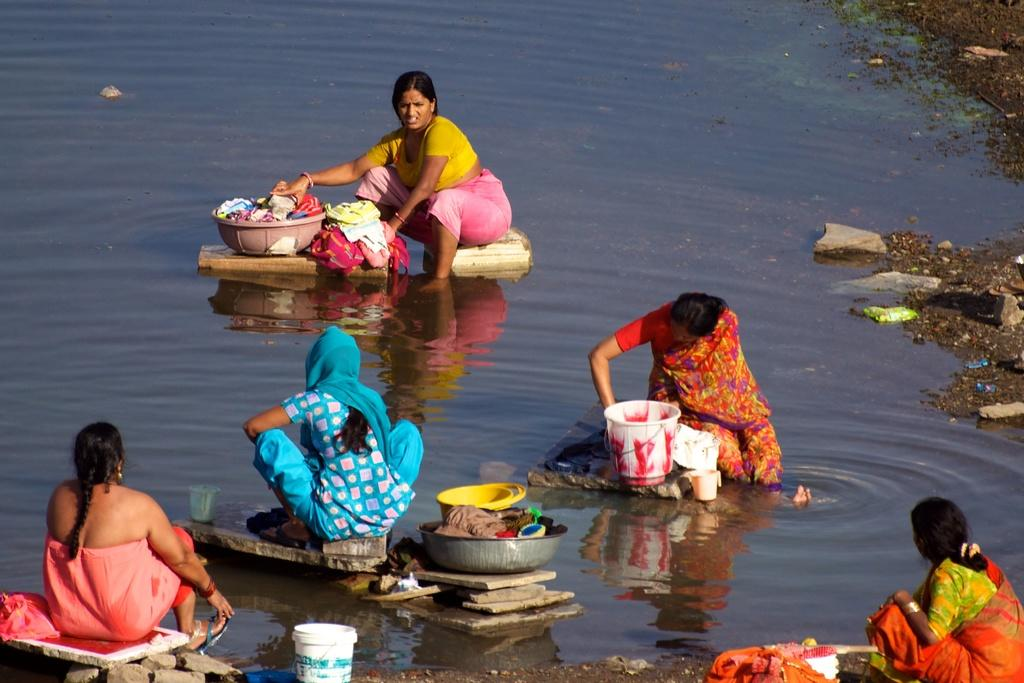Who is present in the image? There are women in the image. What are the women doing in the image? The women are washing clothes. What is necessary for the women to wash clothes in the image? There is water visible in the image. What type of kettle can be seen in the image? There is no kettle present in the image. Which woman's ear is visible in the image? The image does not show any women's ears, as they are likely focused on washing clothes and not facing the camera. 